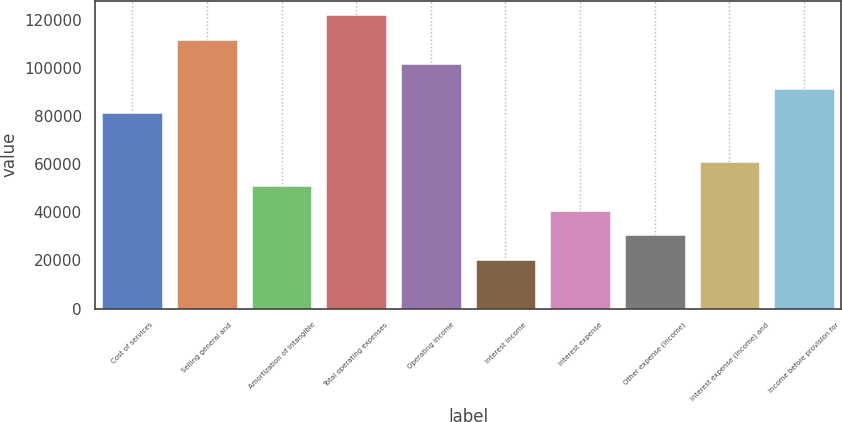Convert chart. <chart><loc_0><loc_0><loc_500><loc_500><bar_chart><fcel>Cost of services<fcel>Selling general and<fcel>Amortization of intangible<fcel>Total operating expenses<fcel>Operating income<fcel>Interest income<fcel>Interest expense<fcel>Other expense (income)<fcel>Interest expense (income) and<fcel>Income before provision for<nl><fcel>81358.4<fcel>111868<fcel>50849.1<fcel>122038<fcel>101698<fcel>20339.8<fcel>40679.3<fcel>30509.5<fcel>61018.9<fcel>91528.2<nl></chart> 